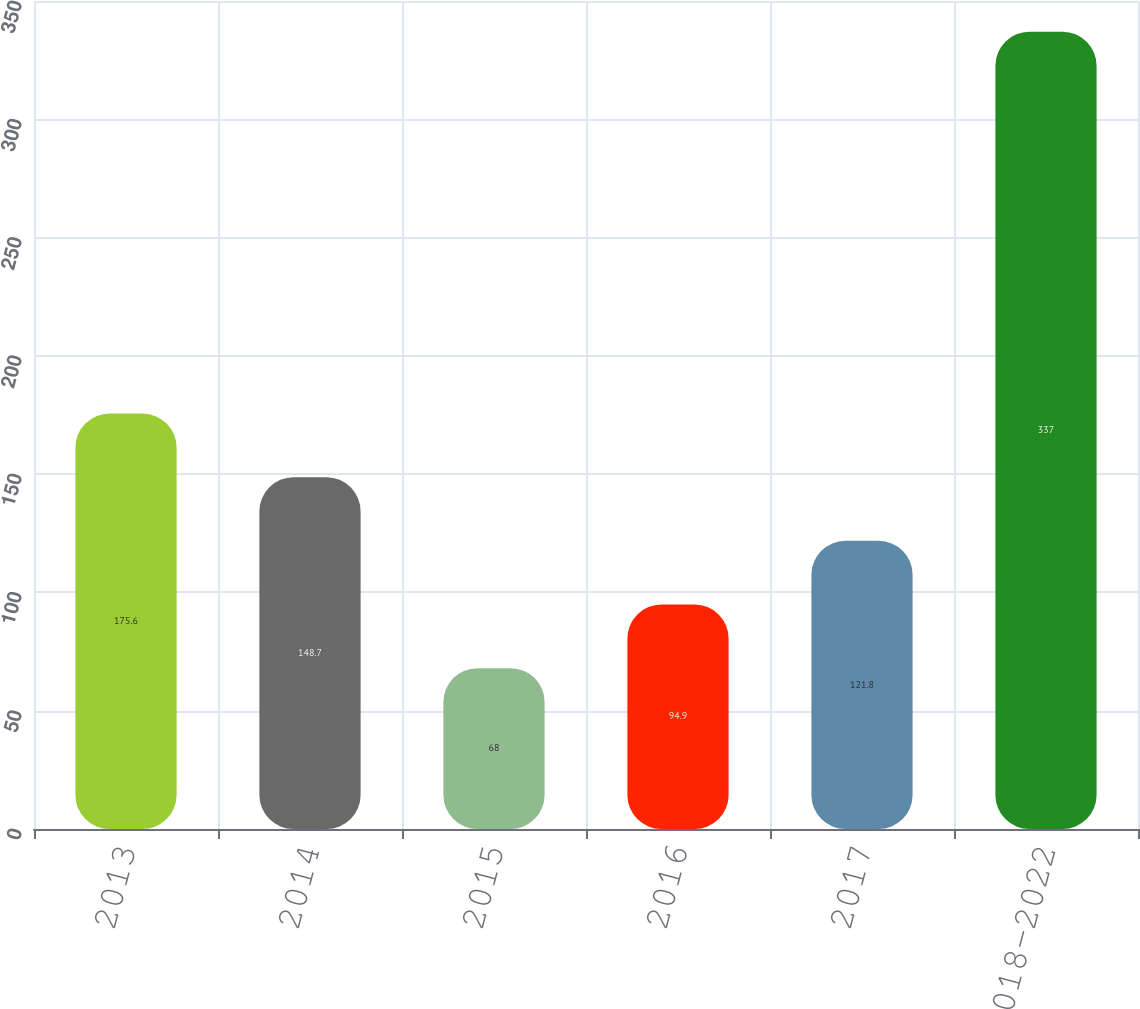Convert chart to OTSL. <chart><loc_0><loc_0><loc_500><loc_500><bar_chart><fcel>2013<fcel>2014<fcel>2015<fcel>2016<fcel>2017<fcel>Years 2018-2022<nl><fcel>175.6<fcel>148.7<fcel>68<fcel>94.9<fcel>121.8<fcel>337<nl></chart> 